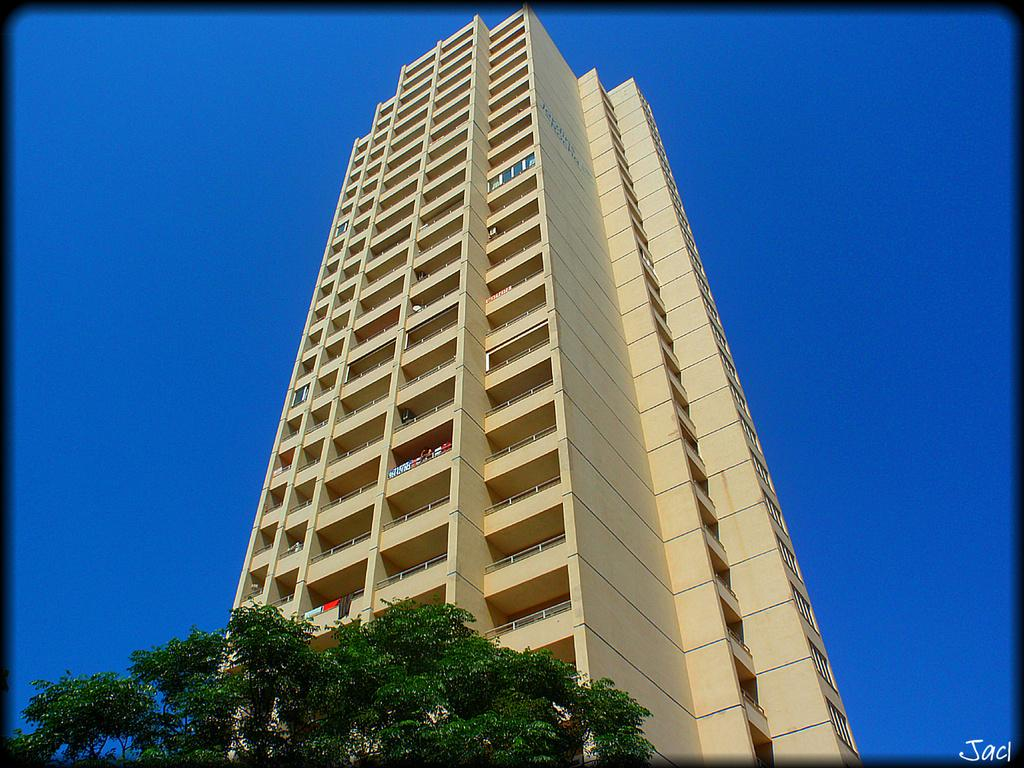What type of natural elements can be seen in the image? There are branches and leaves in the image. What else is present in the image besides natural elements? There are clothes and a building visible in the image. What can be seen in the background of the image? The sky is visible in the background of the image. What type of drink is being served in the crib in the image? There is no crib or drink present in the image. 